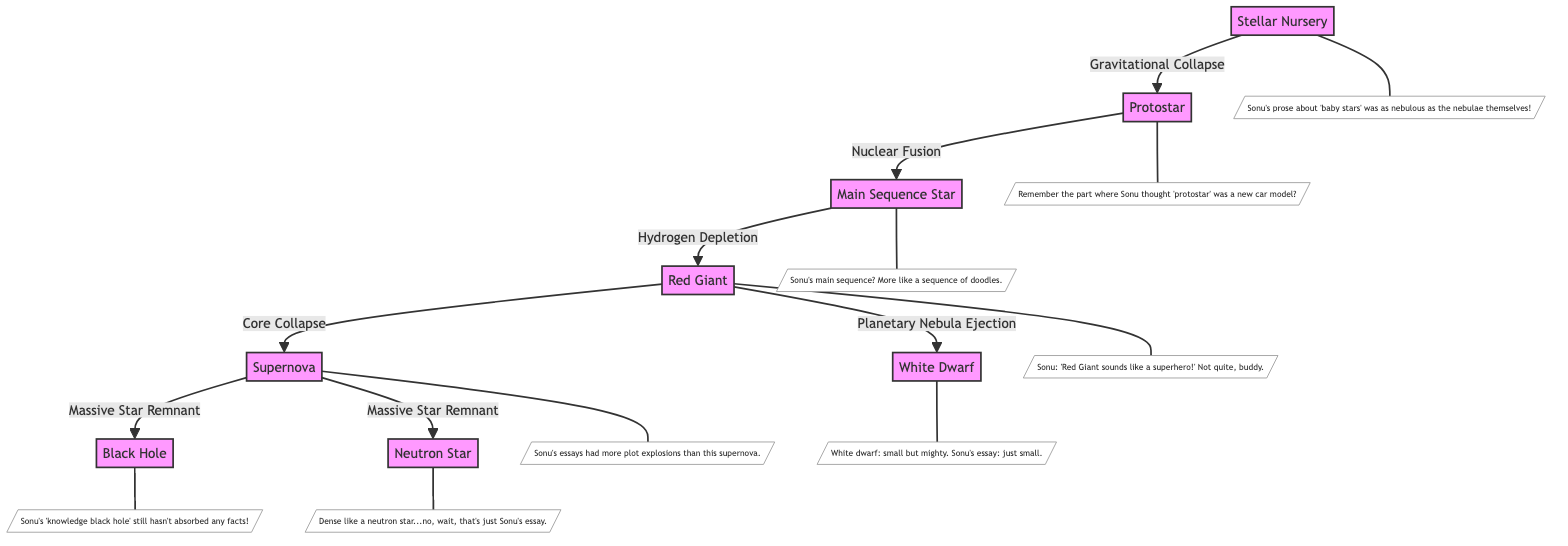What is the first stage of star evolution in the diagram? The diagram presents the process of star evolution starting from the first node, which is labeled "Stellar Nursery." This is clearly indicated as the initial stage where stars begin to form.
Answer: Stellar Nursery How many total stages of star evolution are illustrated in the diagram? By counting the distinct nodes in the diagram, it can be determined that there are a total of seven stages, which include the Stellar Nursery, Protostar, Main Sequence Star, Red Giant, Supernova, Black Hole, White Dwarf, and Neutron Star.
Answer: Seven What process transforms a Protostar into a Main Sequence Star? The diagram indicates that the transformation from a Protostar to a Main Sequence Star is driven by the process of "Nuclear Fusion," signifying the beginning of a star's active life as it starts to fuse hydrogen into helium.
Answer: Nuclear Fusion What happens to a Red Giant when it undergoes core collapse? According to the diagram, when a Red Giant undergoes core collapse, it leads to a Supernova event, which is shown as one of the primary pathways following the Red Giant stage.
Answer: Supernova Which star remnant does a Supernova lead to if it is a massive star? The diagram shows that a Supernova can result in two types of stellar remnants: a Black Hole and a Neutron Star. This indicates the potential end states for massive stars following a Supernova event.
Answer: Black Hole and Neutron Star What happens to a Red Giant that is not a massive star? The diagram illustrates that for a Red Giant that is not massive, it will eject a Planetary Nebula, leading to the formation of a White Dwarf. This indicates the fate of lower-mass stars.
Answer: White Dwarf In Sonu's annotations, how does he refer to a Neutron Star? The annotation specifically describes Sonu's comparison of the density of a Neutron Star to "Sonu's essay," highlighting a humorous reflection on the content and quality of his writing.
Answer: Dense like a neutron star What humorous comment does Sonu make about Main Sequence Stars? The annotation associated with the Main Sequence Star contains the quip that Sonu's rendition was "more like a sequence of doodles," showcasing a light-hearted critique of his essay's substance and coherence.
Answer: More like a sequence of doodles What is the relationship between Stellar Nursery and Protostar in the diagram? The diagram indicates that the relationship between Stellar Nursery and Protostar is a direct pathway illustrated as "Gravitational Collapse," signifying how stellar material collapses to form protostars.
Answer: Gravitational Collapse 